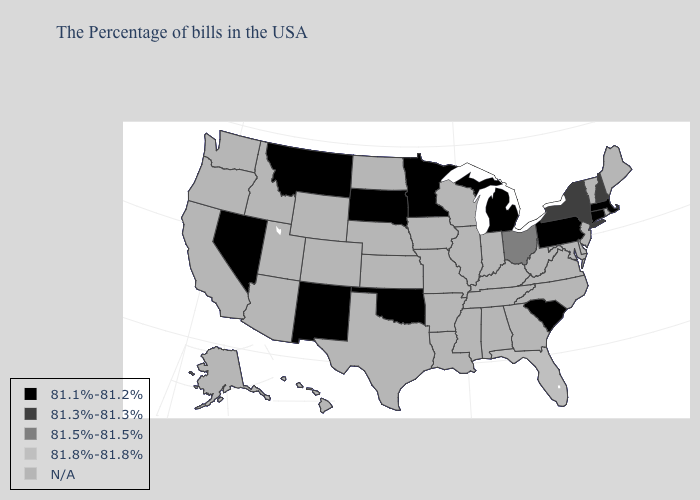What is the value of Vermont?
Short answer required. N/A. Name the states that have a value in the range 81.8%-81.8%?
Keep it brief. Florida. Name the states that have a value in the range 81.5%-81.5%?
Give a very brief answer. Ohio. Does the map have missing data?
Answer briefly. Yes. What is the value of Minnesota?
Answer briefly. 81.1%-81.2%. What is the value of Mississippi?
Give a very brief answer. N/A. What is the highest value in states that border Vermont?
Quick response, please. 81.3%-81.3%. What is the highest value in the USA?
Be succinct. 81.8%-81.8%. Does Ohio have the lowest value in the USA?
Short answer required. No. What is the value of New York?
Give a very brief answer. 81.3%-81.3%. 